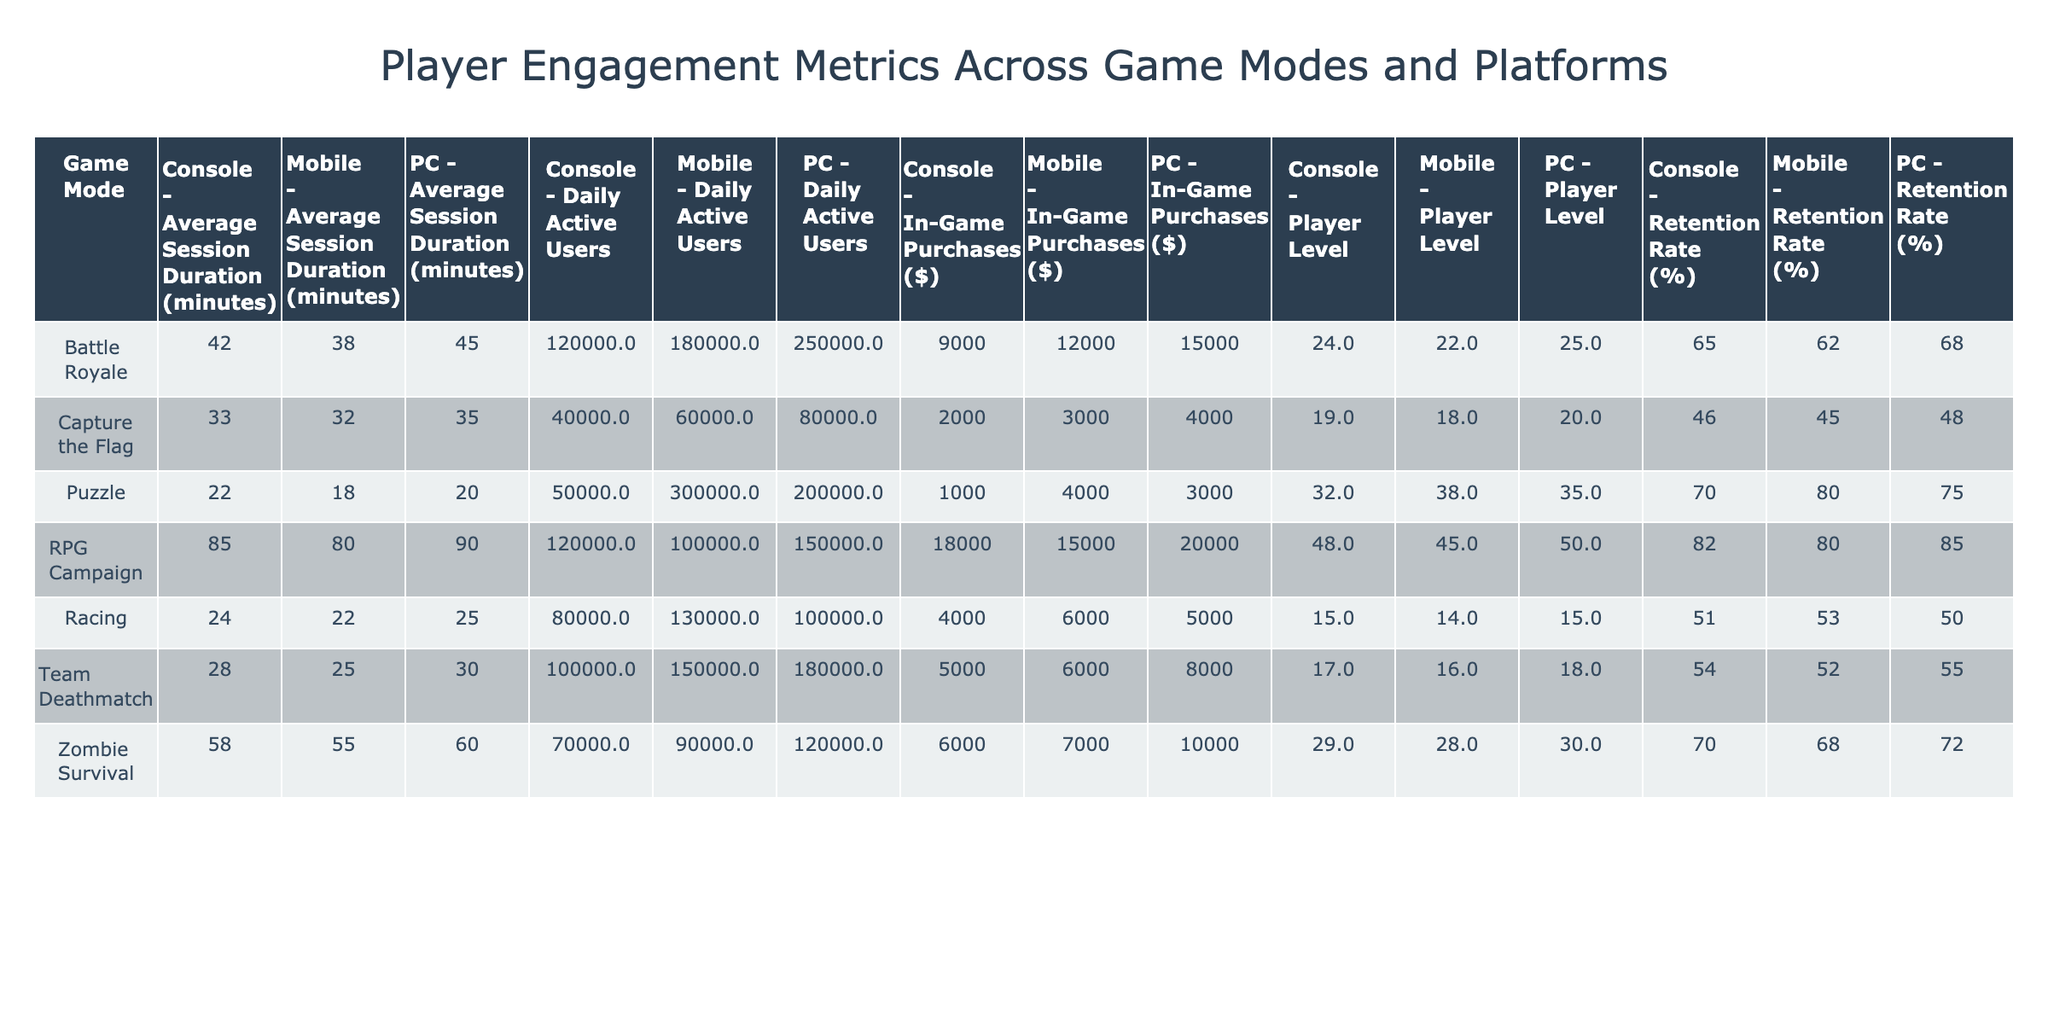What is the Daily Active Users count for the Puzzle game mode on the Mobile platform? The table shows the Daily Active Users for Puzzle in the Mobile column is 300000.
Answer: 300000 Which game mode has the highest Average Session Duration on the PC platform? By comparing the Average Session Duration for all game modes on the PC platform, RPG Campaign has the highest value at 90 minutes.
Answer: 90 What is the average Retention Rate across all game modes on the Console platform? Summing the Retention Rates from the Console platform: (65 + 54 + 46 + 70 + 82) = 317. There are 5 game modes, so the average is 317/5 = 63.4.
Answer: 63.4 Does the Zombie Survival game mode have a higher Retention Rate on PC compared to Team Deathmatch on Mobile? The Retention Rate for Zombie Survival on PC is 72%, while Team Deathmatch on Mobile is 52%. Since 72% is greater than 52%, the statement is true.
Answer: Yes What is the difference in In-Game Purchases between the Battle Royale mode on PC and the Capture the Flag mode on Mobile? The In-Game Purchases for Battle Royale on PC is $15000, while for Capture the Flag on Mobile it is $3000. The difference is $15000 - $3000 = $12000.
Answer: 12000 What is the total Daily Active Users for Racing mode across all platforms? Adding the Daily Active Users in Racing across all platforms: 100000 (PC) + 130000 (Mobile) + 80000 (Console) = 310000.
Answer: 310000 Is the average Player Level for the RPG Campaign higher on Mobile compared to Battle Royale on PC? The average Player Level for RPG Campaign on Mobile is 45, while for Battle Royale on PC it is 25. Since 45 is greater than 25, the statement is true.
Answer: Yes What is the highest In-Game Purchases value across all game modes on the Mobile platform? Scanning the Mobile column for In-Game Purchases reveals that the value is $4000 for the Puzzle game mode, which is the highest across all mobile game modes.
Answer: 4000 What is the average session duration for Zombie Survival across all platforms? The average session durations for Zombie Survival are 60 (PC), 55 (Mobile), and 58 (Console). Adding them gives 60 + 55 + 58 = 173. Dividing by the number of platforms (3) gives an average of 173/3 = 57.67.
Answer: 57.67 